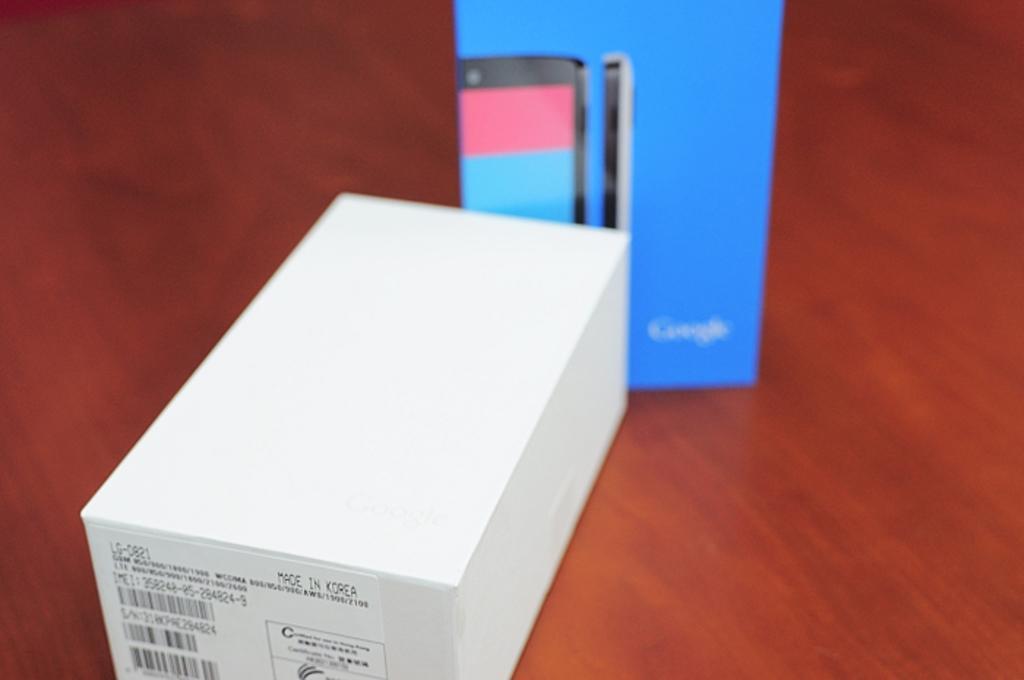<image>
Relay a brief, clear account of the picture shown. a white and blue box on a wooden table with label Made in Korea 